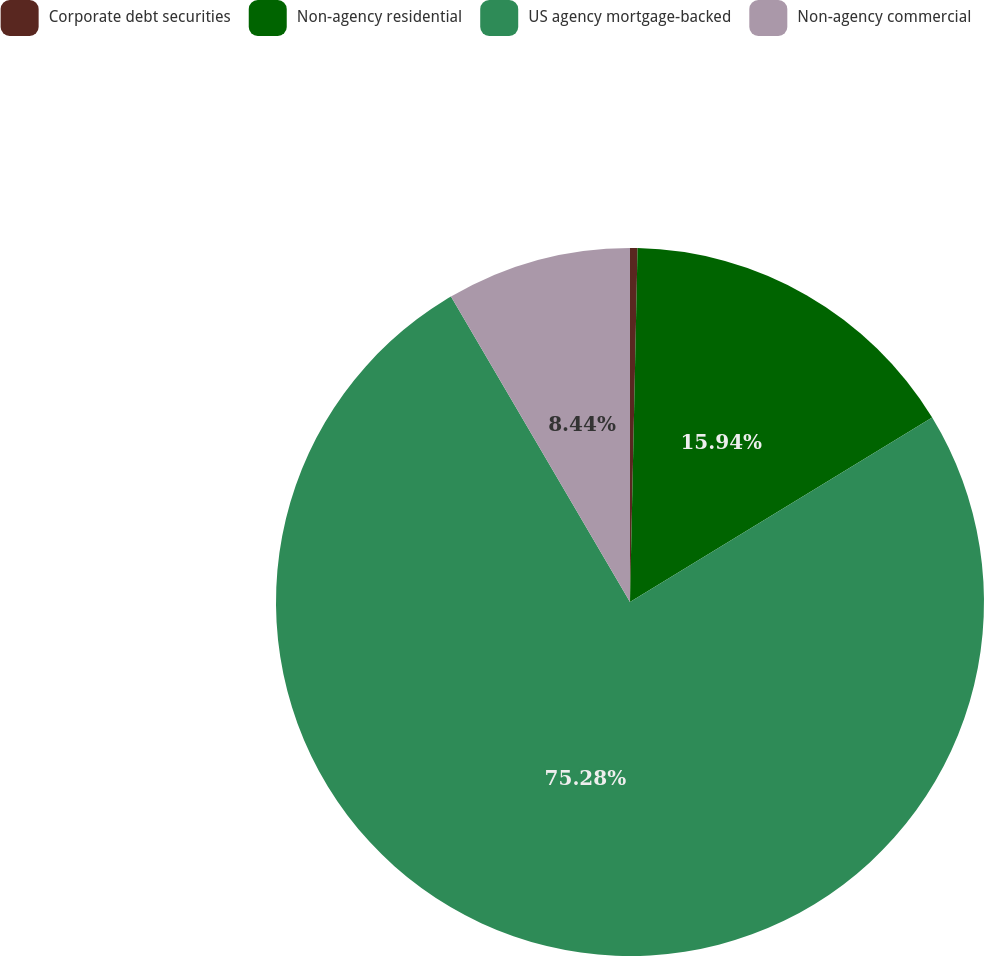Convert chart. <chart><loc_0><loc_0><loc_500><loc_500><pie_chart><fcel>Corporate debt securities<fcel>Non-agency residential<fcel>US agency mortgage-backed<fcel>Non-agency commercial<nl><fcel>0.34%<fcel>15.94%<fcel>75.29%<fcel>8.44%<nl></chart> 